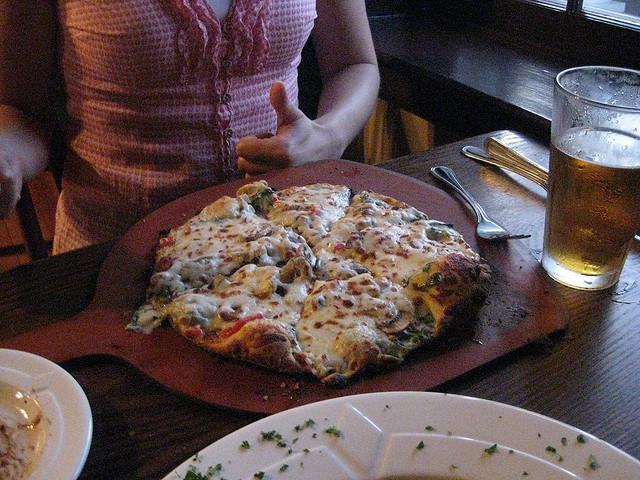Is this women wearing a solid shirt?
Short answer required. No. Is the glass filled to the brim?
Answer briefly. No. Is this in their home?
Write a very short answer. No. 